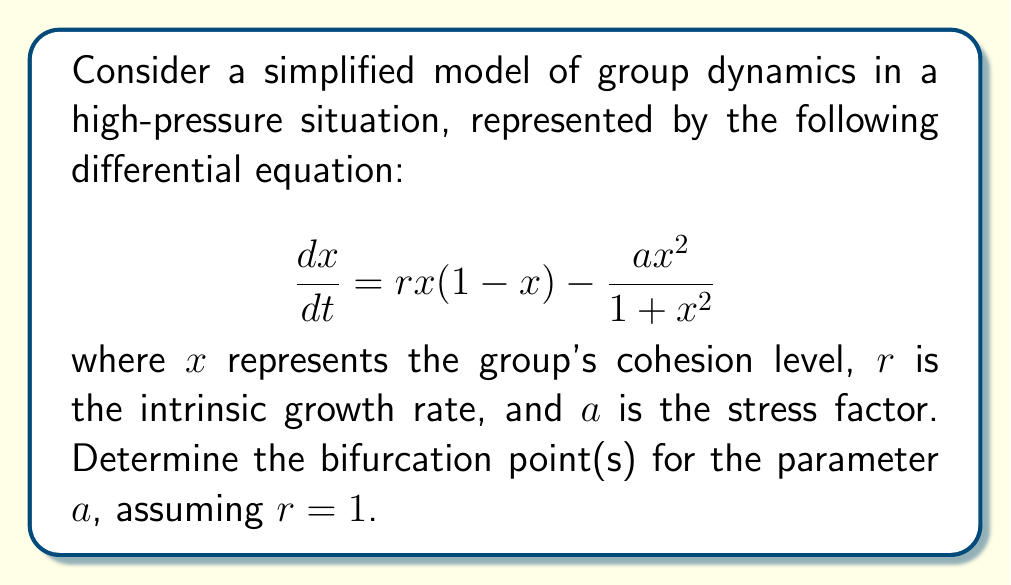Could you help me with this problem? To find the bifurcation points, we need to follow these steps:

1) First, find the equilibrium points by setting $\frac{dx}{dt} = 0$:

   $$rx(1-x) - \frac{ax^2}{1+x^2} = 0$$

2) Substitute $r=1$:

   $$x(1-x) - \frac{ax^2}{1+x^2} = 0$$

3) Multiply both sides by $(1+x^2)$:

   $$x(1-x)(1+x^2) - ax^2 = 0$$

4) Expand:

   $$x + x^3 - x^2 - x^4 - ax^2 = 0$$

5) Rearrange:

   $$x^4 + (a-1)x^2 - x = 0$$

6) For a bifurcation to occur, this equation should have a double root. This happens when the discriminant of the quadratic equation in $x^2$ is zero.

7) Let $y = x^2$. Then we have:

   $$y^2 + (a-1)y - x = 0$$

8) The discriminant of this quadratic is:

   $$\Delta = (a-1)^2 + 4x$$

9) Setting this to zero:

   $$(a-1)^2 + 4x = 0$$

10) Solve for $x$:

    $$x = -\frac{(a-1)^2}{4}$$

11) Substitute this back into the original equation:

    $$\left(-\frac{(a-1)^2}{4}\right)^2 + (a-1)\left(-\frac{(a-1)^2}{4}\right) + \frac{(a-1)^2}{4} = 0$$

12) Simplify:

    $$\frac{(a-1)^4}{16} - \frac{(a-1)^3}{4} + \frac{(a-1)^2}{4} = 0$$

13) Multiply by 16:

    $$(a-1)^4 - 4(a-1)^3 + 4(a-1)^2 = 0$$

14) Factor out $(a-1)^2$:

    $$(a-1)^2((a-1)^2 - 4(a-1) + 4) = 0$$

15) Factor further:

    $$(a-1)^2(a-3)^2 = 0$$

16) Solve:

    $$a = 1 \text{ or } a = 3$$

These are the bifurcation points for the parameter $a$.
Answer: $a = 1$ and $a = 3$ 